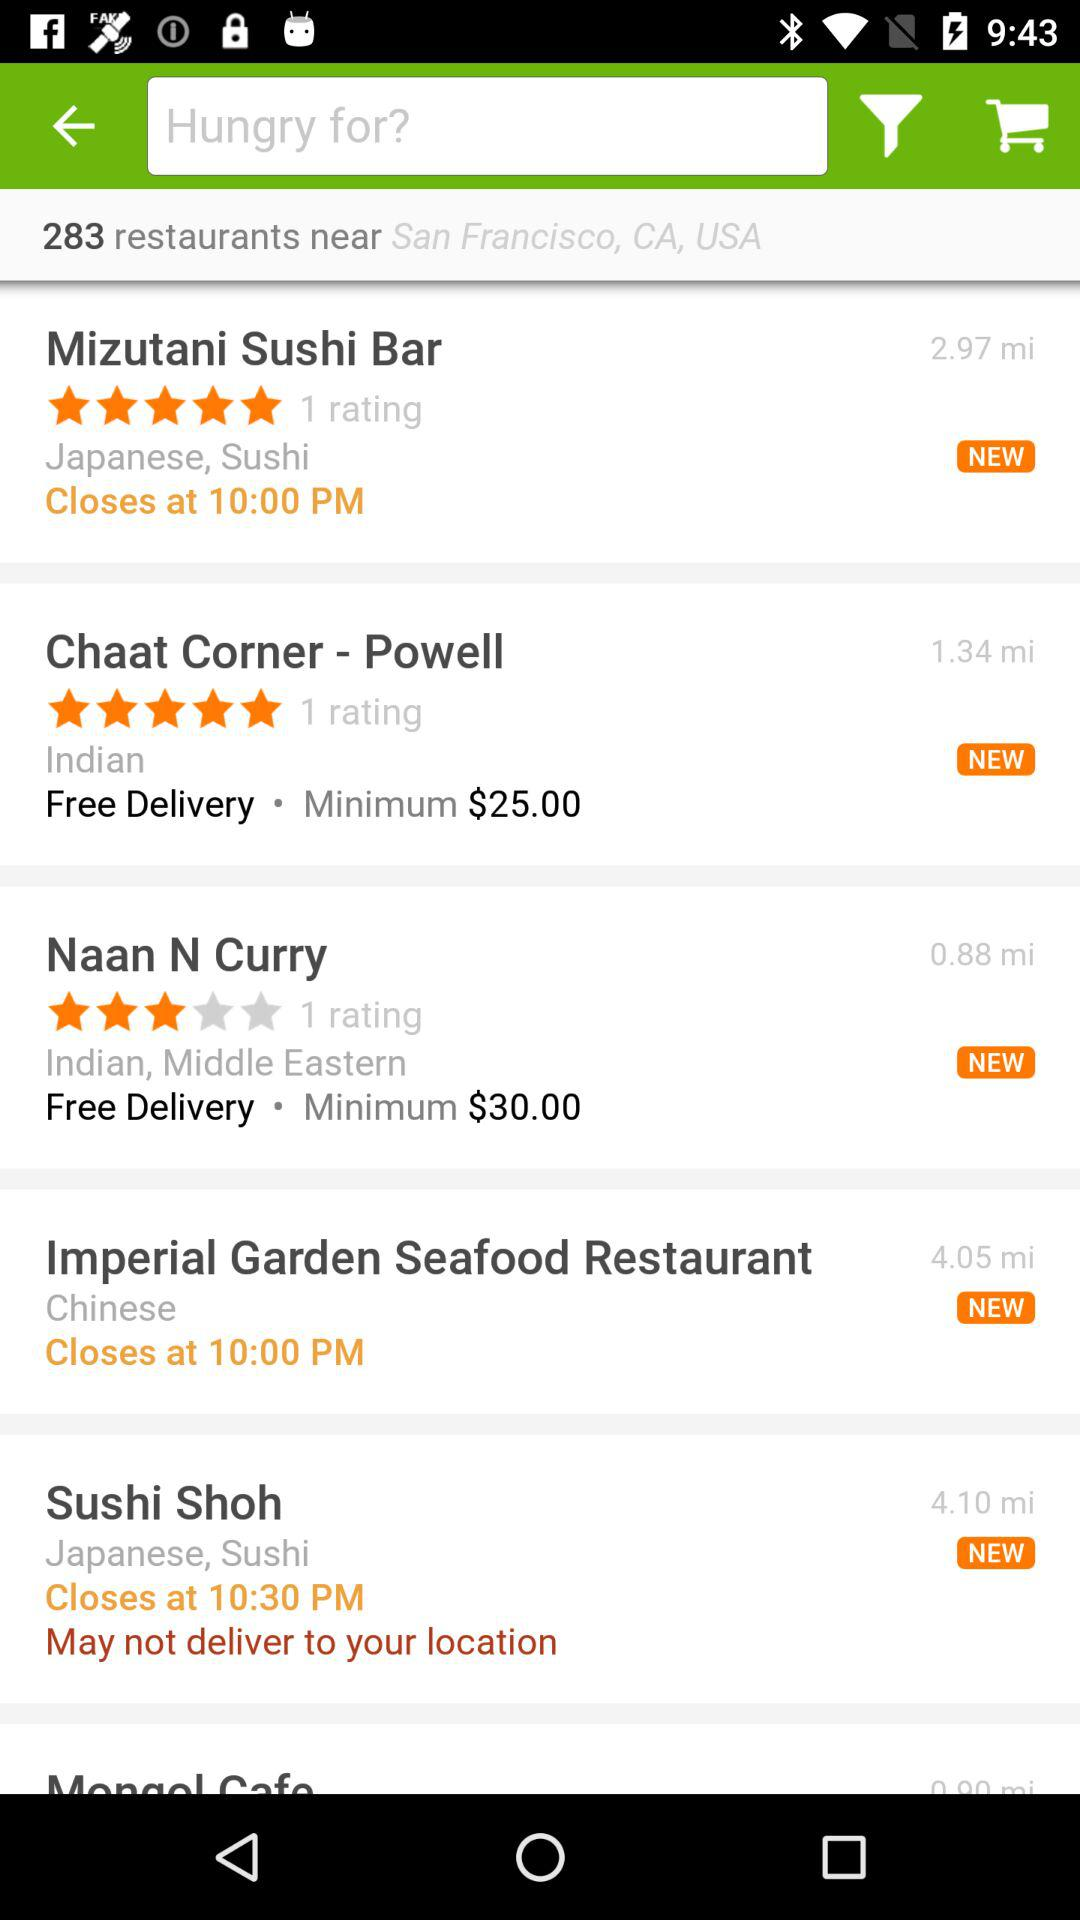What is the closing time of "Sushi Shoh"? The closing time is 10:30 PM. 